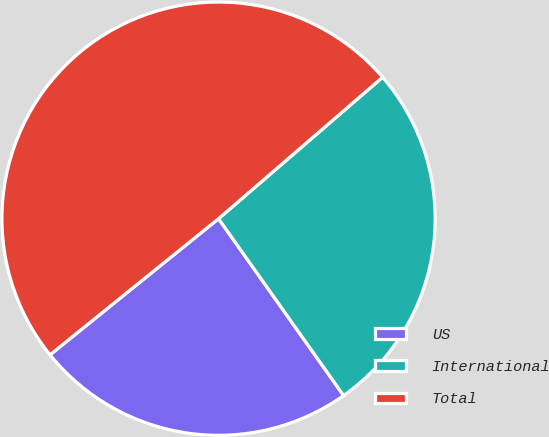Convert chart to OTSL. <chart><loc_0><loc_0><loc_500><loc_500><pie_chart><fcel>US<fcel>International<fcel>Total<nl><fcel>23.98%<fcel>26.53%<fcel>49.49%<nl></chart> 